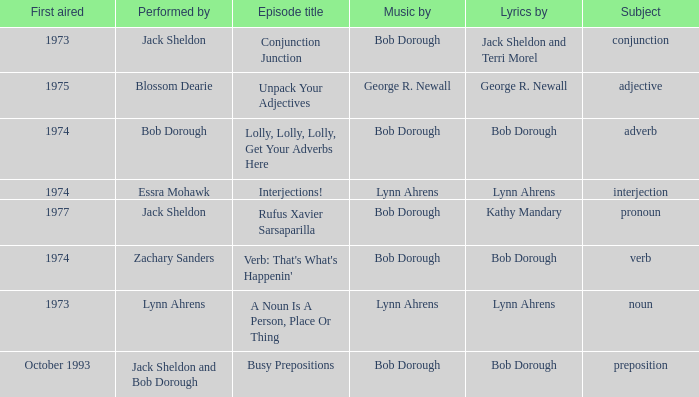When zachary sanders is the entertainer, how many persons is the music created by? 1.0. 